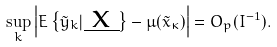Convert formula to latex. <formula><loc_0><loc_0><loc_500><loc_500>\sup _ { k } \left | E \left \{ \tilde { y } _ { k } | \underbar { x } \right \} - \mu ( \tilde { x } _ { \kappa } ) \right | = O _ { p } ( I ^ { - 1 } ) .</formula> 